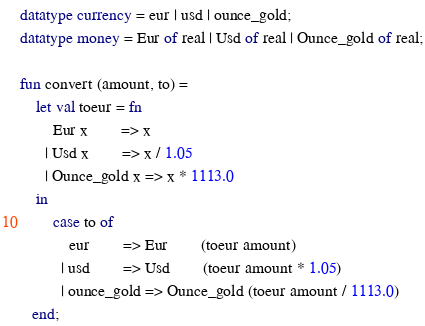Convert code to text. <code><loc_0><loc_0><loc_500><loc_500><_SML_>datatype currency = eur | usd | ounce_gold;
datatype money = Eur of real | Usd of real | Ounce_gold of real;

fun convert (amount, to) =
    let val toeur = fn
        Eur x        => x
      | Usd x        => x / 1.05 
      | Ounce_gold x => x * 1113.0
    in
        case to of
            eur        => Eur        (toeur amount)
          | usd        => Usd        (toeur amount * 1.05)
          | ounce_gold => Ounce_gold (toeur amount / 1113.0)
   end;
</code> 